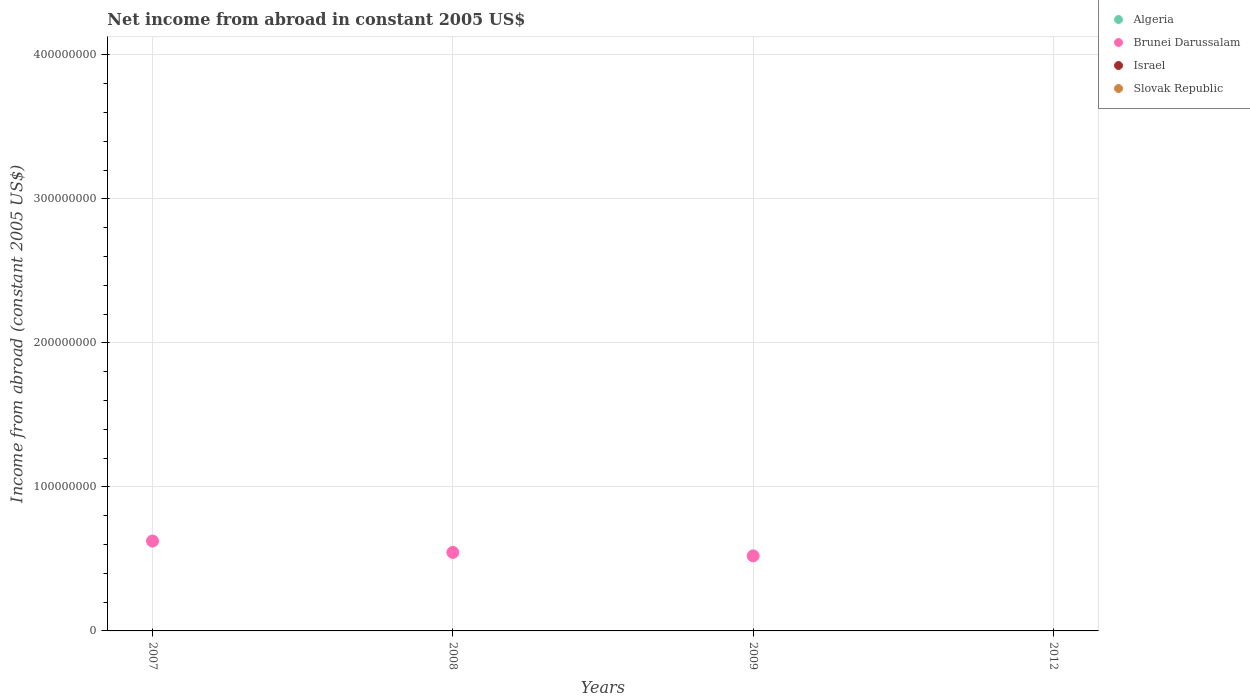How many different coloured dotlines are there?
Keep it short and to the point. 1. Is the number of dotlines equal to the number of legend labels?
Keep it short and to the point. No. What is the net income from abroad in Algeria in 2012?
Offer a very short reply. 0. Across all years, what is the minimum net income from abroad in Israel?
Keep it short and to the point. 0. What is the difference between the net income from abroad in Brunei Darussalam in 2007 and that in 2008?
Make the answer very short. 7.90e+06. What is the average net income from abroad in Algeria per year?
Give a very brief answer. 0. In how many years, is the net income from abroad in Algeria greater than 140000000 US$?
Keep it short and to the point. 0. What is the difference between the highest and the second highest net income from abroad in Brunei Darussalam?
Offer a very short reply. 7.90e+06. What is the difference between the highest and the lowest net income from abroad in Brunei Darussalam?
Your response must be concise. 6.24e+07. In how many years, is the net income from abroad in Algeria greater than the average net income from abroad in Algeria taken over all years?
Your answer should be compact. 0. Does the net income from abroad in Algeria monotonically increase over the years?
Your answer should be compact. No. Is the net income from abroad in Slovak Republic strictly less than the net income from abroad in Brunei Darussalam over the years?
Your answer should be compact. Yes. How many dotlines are there?
Provide a short and direct response. 1. How many years are there in the graph?
Your response must be concise. 4. Are the values on the major ticks of Y-axis written in scientific E-notation?
Provide a succinct answer. No. Does the graph contain any zero values?
Your answer should be compact. Yes. Does the graph contain grids?
Ensure brevity in your answer.  Yes. Where does the legend appear in the graph?
Keep it short and to the point. Top right. How many legend labels are there?
Offer a terse response. 4. What is the title of the graph?
Your answer should be compact. Net income from abroad in constant 2005 US$. What is the label or title of the X-axis?
Make the answer very short. Years. What is the label or title of the Y-axis?
Provide a succinct answer. Income from abroad (constant 2005 US$). What is the Income from abroad (constant 2005 US$) in Algeria in 2007?
Ensure brevity in your answer.  0. What is the Income from abroad (constant 2005 US$) of Brunei Darussalam in 2007?
Ensure brevity in your answer.  6.24e+07. What is the Income from abroad (constant 2005 US$) in Algeria in 2008?
Your response must be concise. 0. What is the Income from abroad (constant 2005 US$) of Brunei Darussalam in 2008?
Keep it short and to the point. 5.45e+07. What is the Income from abroad (constant 2005 US$) in Slovak Republic in 2008?
Your response must be concise. 0. What is the Income from abroad (constant 2005 US$) in Brunei Darussalam in 2009?
Your response must be concise. 5.21e+07. What is the Income from abroad (constant 2005 US$) in Israel in 2009?
Ensure brevity in your answer.  0. What is the Income from abroad (constant 2005 US$) in Israel in 2012?
Your answer should be very brief. 0. Across all years, what is the maximum Income from abroad (constant 2005 US$) in Brunei Darussalam?
Your answer should be very brief. 6.24e+07. What is the total Income from abroad (constant 2005 US$) of Brunei Darussalam in the graph?
Your response must be concise. 1.69e+08. What is the total Income from abroad (constant 2005 US$) in Israel in the graph?
Your answer should be very brief. 0. What is the difference between the Income from abroad (constant 2005 US$) in Brunei Darussalam in 2007 and that in 2008?
Keep it short and to the point. 7.90e+06. What is the difference between the Income from abroad (constant 2005 US$) of Brunei Darussalam in 2007 and that in 2009?
Your answer should be compact. 1.03e+07. What is the difference between the Income from abroad (constant 2005 US$) in Brunei Darussalam in 2008 and that in 2009?
Your answer should be very brief. 2.40e+06. What is the average Income from abroad (constant 2005 US$) of Algeria per year?
Offer a terse response. 0. What is the average Income from abroad (constant 2005 US$) of Brunei Darussalam per year?
Offer a terse response. 4.23e+07. What is the average Income from abroad (constant 2005 US$) of Israel per year?
Ensure brevity in your answer.  0. What is the average Income from abroad (constant 2005 US$) in Slovak Republic per year?
Ensure brevity in your answer.  0. What is the ratio of the Income from abroad (constant 2005 US$) of Brunei Darussalam in 2007 to that in 2008?
Provide a short and direct response. 1.15. What is the ratio of the Income from abroad (constant 2005 US$) of Brunei Darussalam in 2007 to that in 2009?
Provide a short and direct response. 1.2. What is the ratio of the Income from abroad (constant 2005 US$) in Brunei Darussalam in 2008 to that in 2009?
Your answer should be very brief. 1.05. What is the difference between the highest and the second highest Income from abroad (constant 2005 US$) of Brunei Darussalam?
Your answer should be very brief. 7.90e+06. What is the difference between the highest and the lowest Income from abroad (constant 2005 US$) in Brunei Darussalam?
Ensure brevity in your answer.  6.24e+07. 